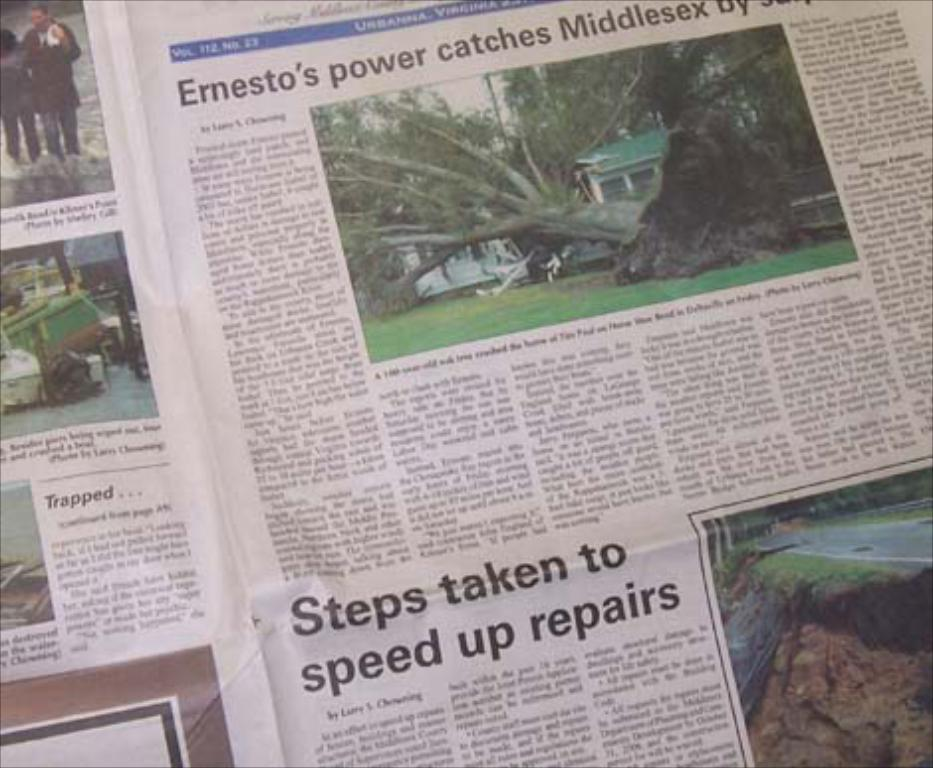What is the main object visible in the image? There is a newspaper in the image. Can you describe the appearance of the newspaper? The newspaper appears to be folded and may have some articles or headlines visible. What might someone do with the newspaper in the image? Someone might read the newspaper or use it to wrap something. What type of worm can be seen crawling on the grass in the image? There is no grass or worm present in the image; it only features a newspaper. 